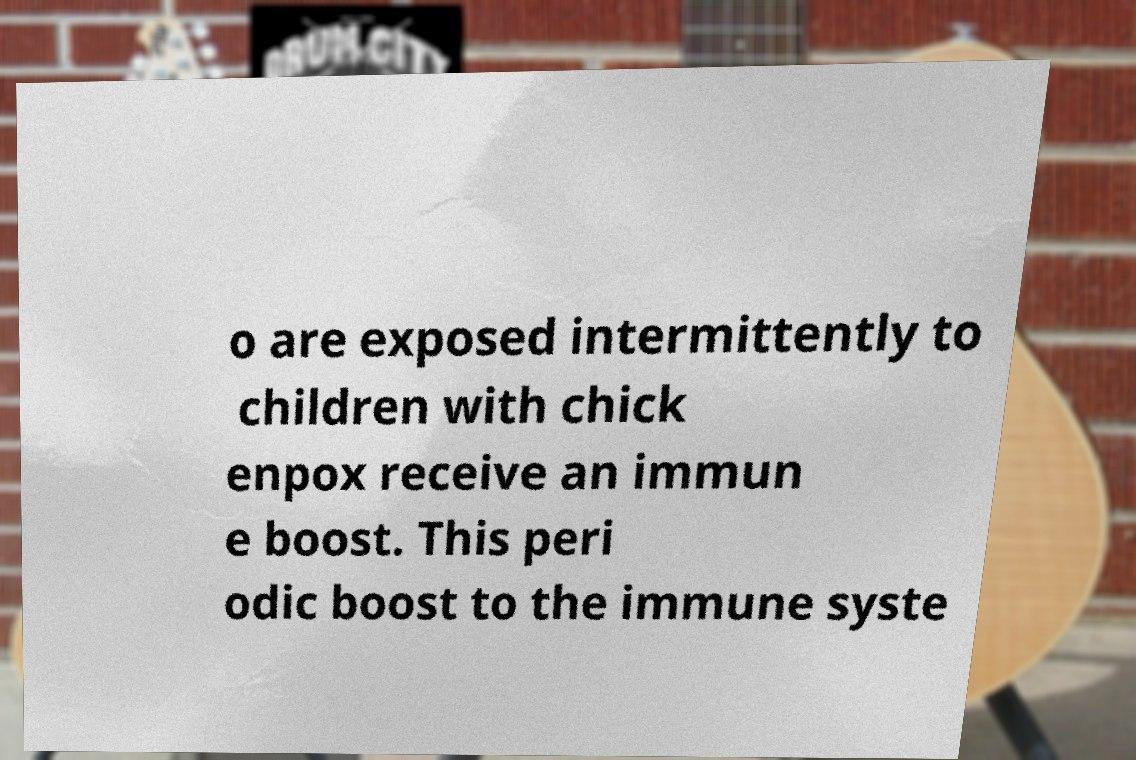Could you assist in decoding the text presented in this image and type it out clearly? o are exposed intermittently to children with chick enpox receive an immun e boost. This peri odic boost to the immune syste 